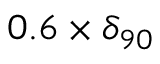Convert formula to latex. <formula><loc_0><loc_0><loc_500><loc_500>0 . 6 \times \delta _ { 9 0 }</formula> 